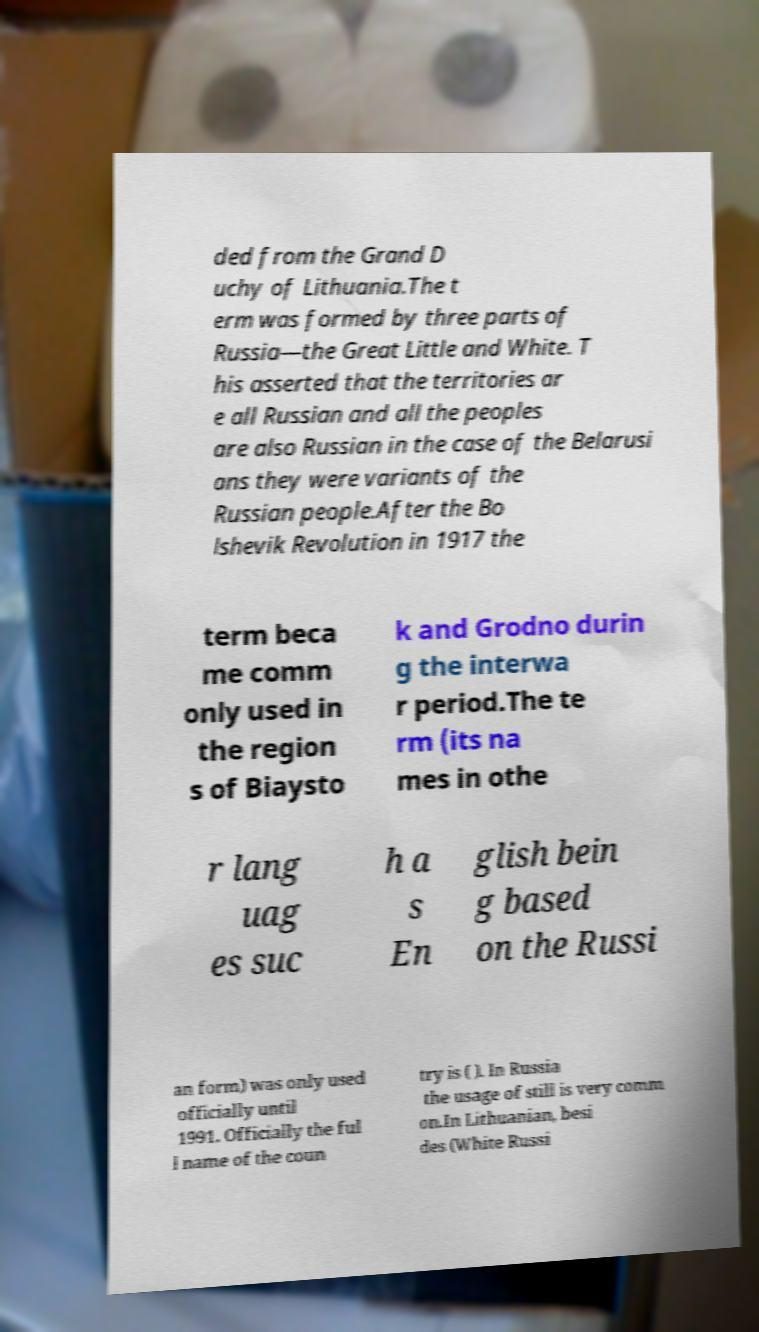Could you assist in decoding the text presented in this image and type it out clearly? ded from the Grand D uchy of Lithuania.The t erm was formed by three parts of Russia—the Great Little and White. T his asserted that the territories ar e all Russian and all the peoples are also Russian in the case of the Belarusi ans they were variants of the Russian people.After the Bo lshevik Revolution in 1917 the term beca me comm only used in the region s of Biaysto k and Grodno durin g the interwa r period.The te rm (its na mes in othe r lang uag es suc h a s En glish bein g based on the Russi an form) was only used officially until 1991. Officially the ful l name of the coun try is ( ). In Russia the usage of still is very comm on.In Lithuanian, besi des (White Russi 